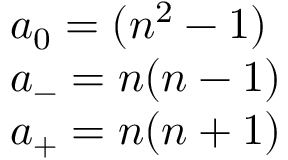<formula> <loc_0><loc_0><loc_500><loc_500>\begin{array} { l c r } { { a _ { 0 } = ( { n ^ { 2 } } - 1 ) } } \\ { { a _ { - } = n ( n - 1 ) } } \\ { { a _ { + } = n ( n + 1 ) } } \end{array}</formula> 